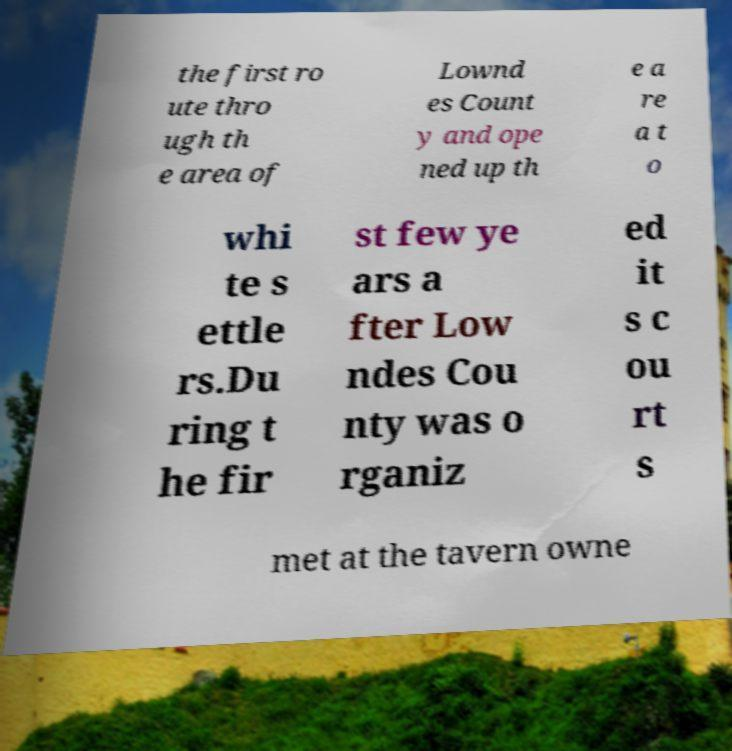There's text embedded in this image that I need extracted. Can you transcribe it verbatim? the first ro ute thro ugh th e area of Lownd es Count y and ope ned up th e a re a t o whi te s ettle rs.Du ring t he fir st few ye ars a fter Low ndes Cou nty was o rganiz ed it s c ou rt s met at the tavern owne 